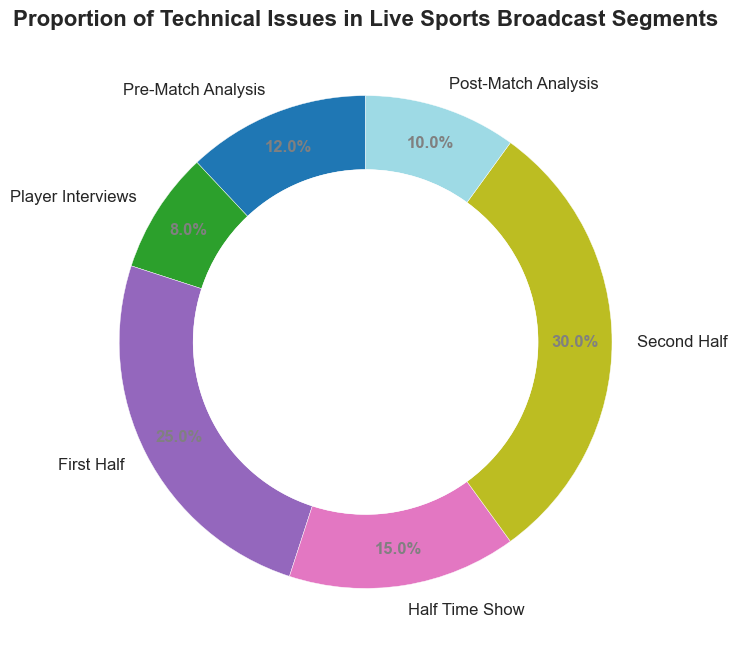What percentage of technical issues occurred during the First Half? Refer to the ring chart where the proportion of technical issues for the First Half is labeled as 25%.
Answer: 25% Which segment had the highest proportion of technical issues? Refer to the section of the ring chart with the largest proportion. The Second Half has the highest proportion with 30%.
Answer: Second Half Compare the proportion of technical issues between the Pre-Match Analysis and Player Interviews. Which one has more? The Pre-Match Analysis segment has a proportion of 12%, while Player Interviews have 8%. 12% is greater than 8%.
Answer: Pre-Match Analysis What is the combined proportion of technical issues occurring during the First Half and Second Half? Add the proportions of the First Half (25%) and Second Half (30%). 25% + 30% = 55%.
Answer: 55% Which segment had the least proportion of technical issues? Refer to the section of the ring chart with the smallest proportion. Player Interviews have the smallest proportion with 8%.
Answer: Player Interviews If you combine the technical issues from the Half Time Show and Post-Match Analysis, what is their total proportion? Add the proportions of the Half Time Show (15%) and Post-Match Analysis (10%). 15% + 10% = 25%.
Answer: 25% What is the difference in the proportion of technical issues between the Second Half and the Pre-Match Analysis? Subtract the proportion of the Pre-Match Analysis (12%) from the Second Half (30%). 30% - 12% = 18%.
Answer: 18% Considering only the three segments with the highest proportions (First Half, Half Time Show, Second Half), what is their total proportion? Add the proportions of the First Half (25%), Half Time Show (15%), and Second Half (30%). 25% + 15% + 30% = 70%.
Answer: 70% Which segment is represented by the color at the 3 o'clock position on the ring chart? The segment starting at the 3 o’clock position is labeled Pre-Match Analysis.
Answer: Pre-Match Analysis What is the average proportion of technical issues across all segments? Add all proportions (12+08+25+15+30+10), which equals 100. Then divide by the number of segments (6). 100% / 6 = 16.67%.
Answer: 16.67% 